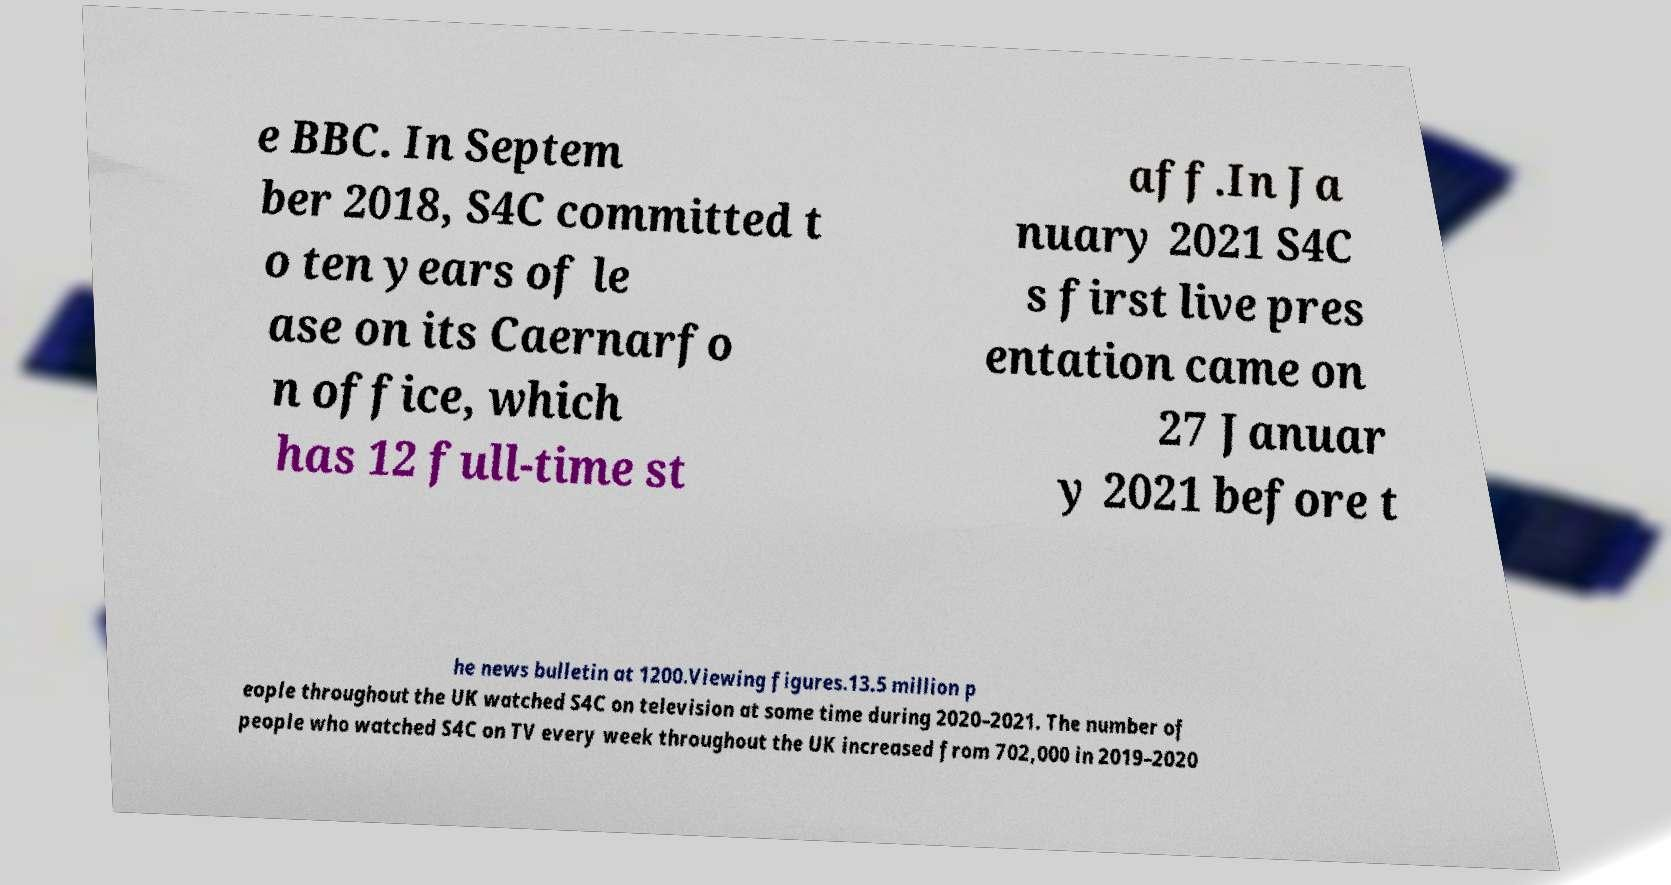Could you extract and type out the text from this image? e BBC. In Septem ber 2018, S4C committed t o ten years of le ase on its Caernarfo n office, which has 12 full-time st aff.In Ja nuary 2021 S4C s first live pres entation came on 27 Januar y 2021 before t he news bulletin at 1200.Viewing figures.13.5 million p eople throughout the UK watched S4C on television at some time during 2020–2021. The number of people who watched S4C on TV every week throughout the UK increased from 702,000 in 2019–2020 